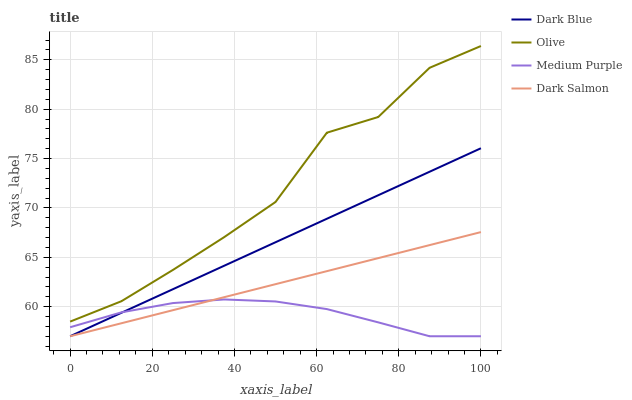Does Medium Purple have the minimum area under the curve?
Answer yes or no. Yes. Does Olive have the maximum area under the curve?
Answer yes or no. Yes. Does Dark Blue have the minimum area under the curve?
Answer yes or no. No. Does Dark Blue have the maximum area under the curve?
Answer yes or no. No. Is Dark Blue the smoothest?
Answer yes or no. Yes. Is Olive the roughest?
Answer yes or no. Yes. Is Medium Purple the smoothest?
Answer yes or no. No. Is Medium Purple the roughest?
Answer yes or no. No. Does Olive have the highest value?
Answer yes or no. Yes. Does Dark Blue have the highest value?
Answer yes or no. No. Is Medium Purple less than Olive?
Answer yes or no. Yes. Is Olive greater than Medium Purple?
Answer yes or no. Yes. Does Medium Purple intersect Dark Salmon?
Answer yes or no. Yes. Is Medium Purple less than Dark Salmon?
Answer yes or no. No. Is Medium Purple greater than Dark Salmon?
Answer yes or no. No. Does Medium Purple intersect Olive?
Answer yes or no. No. 